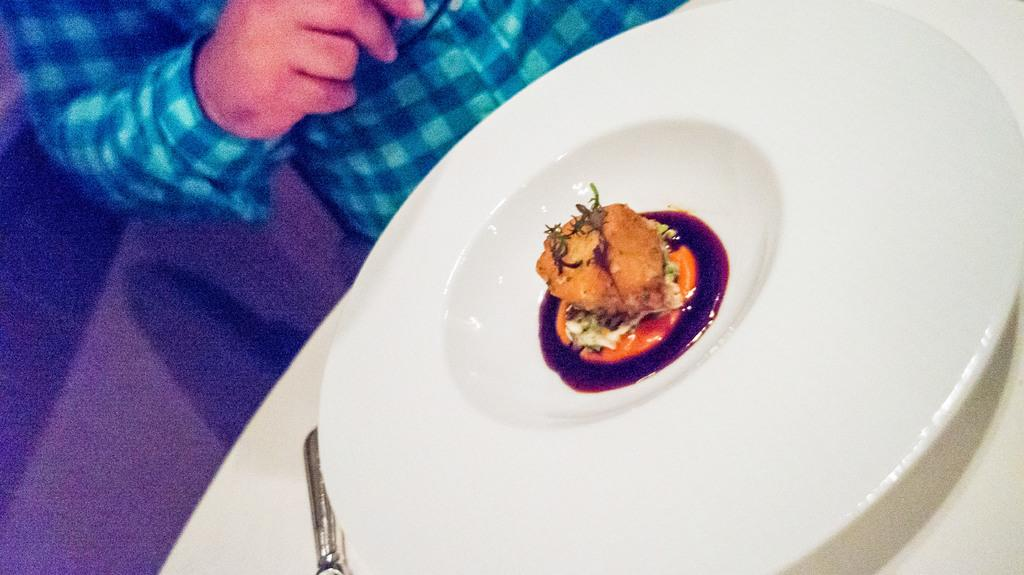Who is present in the image? There is a man in the image. What is the man wearing? The man is wearing a blue t-shirt. What piece of furniture can be seen in the image? There is a table in the image. What is on the table? There is a dish on the table. What type of plantation is visible in the image? There is no plantation present in the image. Is the man in the image a lawyer? The facts provided do not mention the man's profession, so we cannot determine if he is a lawyer. 